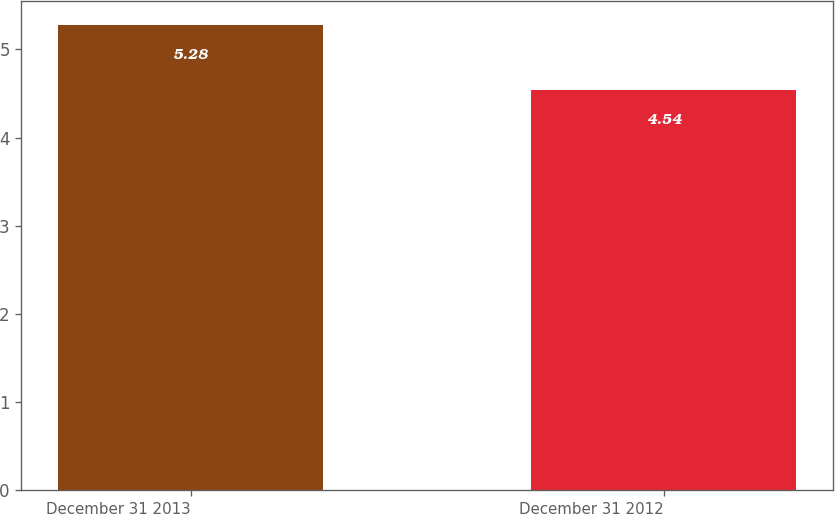Convert chart to OTSL. <chart><loc_0><loc_0><loc_500><loc_500><bar_chart><fcel>December 31 2013<fcel>December 31 2012<nl><fcel>5.28<fcel>4.54<nl></chart> 